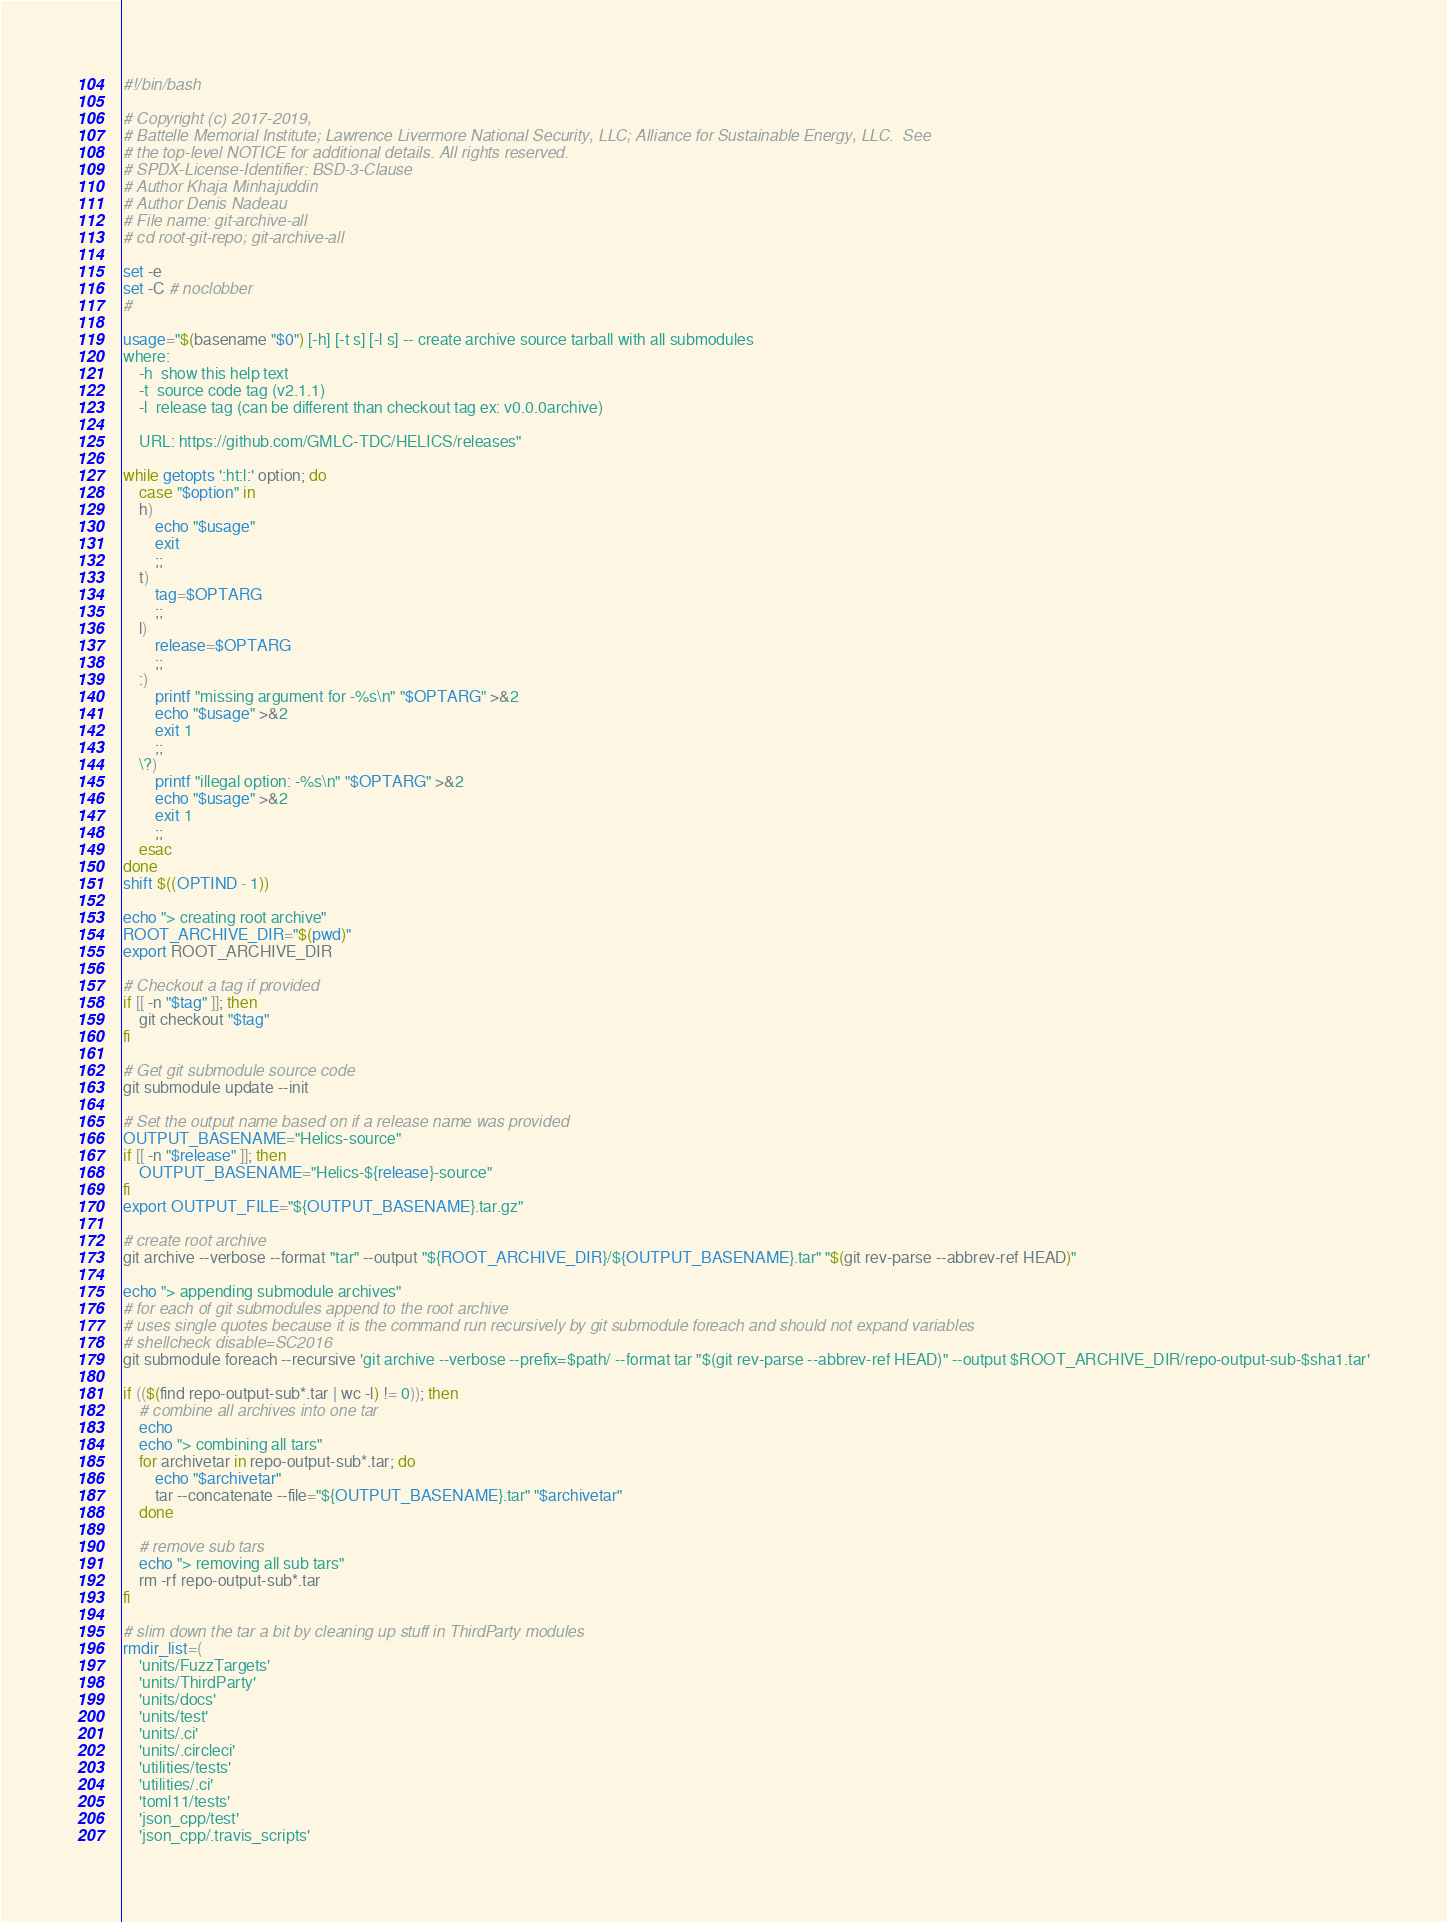<code> <loc_0><loc_0><loc_500><loc_500><_Bash_>#!/bin/bash

# Copyright (c) 2017-2019,
# Battelle Memorial Institute; Lawrence Livermore National Security, LLC; Alliance for Sustainable Energy, LLC.  See
# the top-level NOTICE for additional details. All rights reserved.
# SPDX-License-Identifier: BSD-3-Clause
# Author Khaja Minhajuddin
# Author Denis Nadeau
# File name: git-archive-all
# cd root-git-repo; git-archive-all

set -e
set -C # noclobber
#

usage="$(basename "$0") [-h] [-t s] [-l s] -- create archive source tarball with all submodules
where:
    -h  show this help text
    -t  source code tag (v2.1.1)
    -l  release tag (can be different than checkout tag ex: v0.0.0archive)

    URL: https://github.com/GMLC-TDC/HELICS/releases"

while getopts ':ht:l:' option; do
    case "$option" in
    h)
        echo "$usage"
        exit
        ;;
    t)
        tag=$OPTARG
        ;;
    l)
        release=$OPTARG
        ;;
    :)
        printf "missing argument for -%s\n" "$OPTARG" >&2
        echo "$usage" >&2
        exit 1
        ;;
    \?)
        printf "illegal option: -%s\n" "$OPTARG" >&2
        echo "$usage" >&2
        exit 1
        ;;
    esac
done
shift $((OPTIND - 1))

echo "> creating root archive"
ROOT_ARCHIVE_DIR="$(pwd)"
export ROOT_ARCHIVE_DIR

# Checkout a tag if provided
if [[ -n "$tag" ]]; then
    git checkout "$tag"
fi

# Get git submodule source code
git submodule update --init

# Set the output name based on if a release name was provided
OUTPUT_BASENAME="Helics-source"
if [[ -n "$release" ]]; then
    OUTPUT_BASENAME="Helics-${release}-source"
fi
export OUTPUT_FILE="${OUTPUT_BASENAME}.tar.gz"

# create root archive
git archive --verbose --format "tar" --output "${ROOT_ARCHIVE_DIR}/${OUTPUT_BASENAME}.tar" "$(git rev-parse --abbrev-ref HEAD)"

echo "> appending submodule archives"
# for each of git submodules append to the root archive
# uses single quotes because it is the command run recursively by git submodule foreach and should not expand variables
# shellcheck disable=SC2016
git submodule foreach --recursive 'git archive --verbose --prefix=$path/ --format tar "$(git rev-parse --abbrev-ref HEAD)" --output $ROOT_ARCHIVE_DIR/repo-output-sub-$sha1.tar'

if (($(find repo-output-sub*.tar | wc -l) != 0)); then
    # combine all archives into one tar
    echo
    echo "> combining all tars"
    for archivetar in repo-output-sub*.tar; do
        echo "$archivetar"
        tar --concatenate --file="${OUTPUT_BASENAME}.tar" "$archivetar"
    done

    # remove sub tars
    echo "> removing all sub tars"
    rm -rf repo-output-sub*.tar
fi

# slim down the tar a bit by cleaning up stuff in ThirdParty modules
rmdir_list=(
    'units/FuzzTargets'
    'units/ThirdParty'
    'units/docs'
    'units/test'
    'units/.ci'
    'units/.circleci'
    'utilities/tests'
    'utilities/.ci'
    'toml11/tests'
    'json_cpp/test'
    'json_cpp/.travis_scripts'</code> 